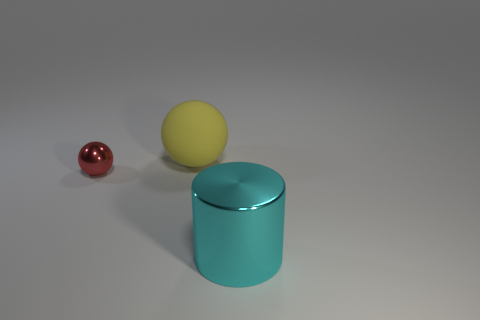Is there any other thing that is made of the same material as the yellow ball?
Keep it short and to the point. No. Is the shape of the big thing in front of the rubber object the same as the metallic object to the left of the cyan object?
Provide a succinct answer. No. The big shiny cylinder has what color?
Ensure brevity in your answer.  Cyan. What number of matte objects are either red balls or cyan things?
Ensure brevity in your answer.  0. What is the color of the other thing that is the same shape as the yellow matte thing?
Make the answer very short. Red. Is there a tiny blue matte cylinder?
Provide a short and direct response. No. Do the sphere that is on the right side of the tiny red shiny ball and the sphere that is in front of the large matte sphere have the same material?
Make the answer very short. No. What number of objects are either objects that are right of the red object or metal things that are on the right side of the red object?
Keep it short and to the point. 2. There is a shiny thing that is on the left side of the cyan cylinder; does it have the same color as the big thing that is right of the large ball?
Your response must be concise. No. What is the shape of the object that is in front of the big yellow matte sphere and right of the red object?
Your answer should be compact. Cylinder. 